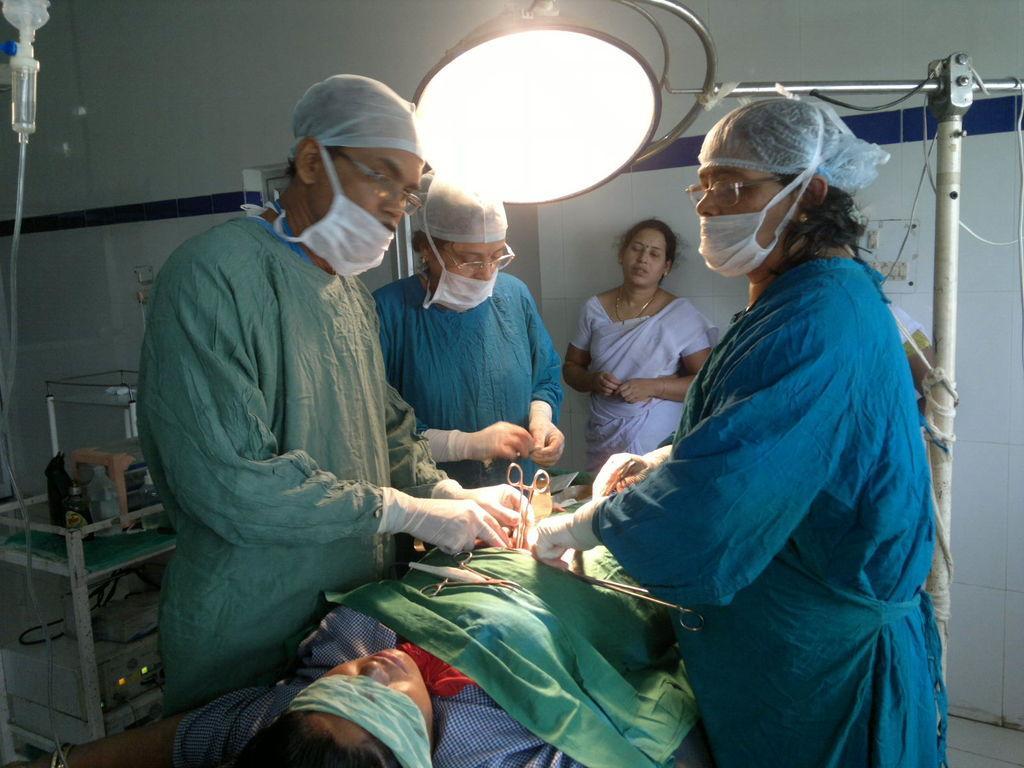Can you describe this image briefly? this image there are three people wearing mask, one person holding scissors , one person laying , there is a cloth on him, there is the wall, in front of the wall there is a woman, at the top there is a light, on the right side there is a stand, on the left side there is an equipment, Cline. 